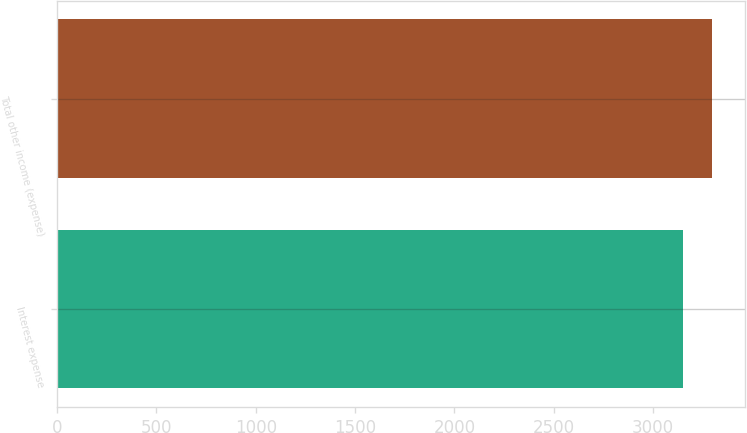Convert chart. <chart><loc_0><loc_0><loc_500><loc_500><bar_chart><fcel>Interest expense<fcel>Total other income (expense)<nl><fcel>3152<fcel>3299<nl></chart> 